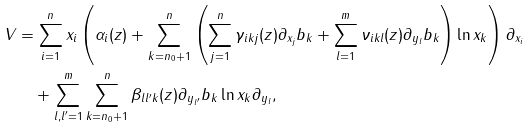<formula> <loc_0><loc_0><loc_500><loc_500>V & = \sum _ { i = 1 } ^ { n } x _ { i } \left ( \alpha _ { i } ( z ) + \sum _ { k = n _ { 0 } + 1 } ^ { n } \left ( \sum _ { j = 1 } ^ { n } \gamma _ { i k j } ( z ) \partial _ { x _ { j } } b _ { k } + \sum _ { l = 1 } ^ { m } \nu _ { i k l } ( z ) \partial _ { y _ { l } } b _ { k } \right ) \ln x _ { k } \right ) \partial _ { x _ { i } } \\ & \quad + \sum _ { l , l ^ { \prime } = 1 } ^ { m } \sum _ { k = n _ { 0 } + 1 } ^ { n } \beta _ { l l ^ { \prime } k } ( z ) \partial _ { y _ { l ^ { \prime } } } b _ { k } \ln x _ { k } \partial _ { y _ { l } } ,</formula> 